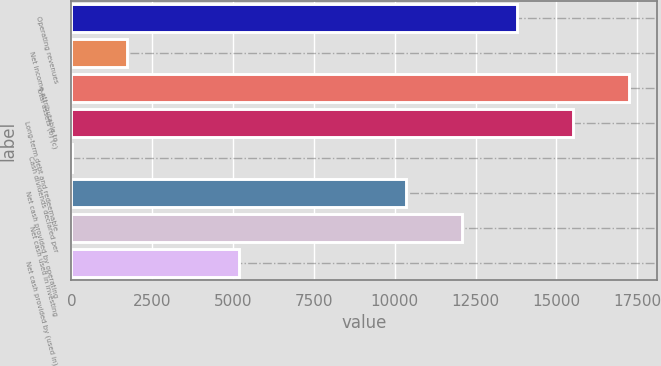Convert chart. <chart><loc_0><loc_0><loc_500><loc_500><bar_chart><fcel>Operating revenues<fcel>Net income attributable to<fcel>Total assets (b) (c)<fcel>Long-term debt and redeemable<fcel>Cash dividends declared per<fcel>Net cash provided by operating<fcel>Net cash used in investing<fcel>Net cash provided by (used in)<nl><fcel>13793<fcel>1725.32<fcel>17241<fcel>15517<fcel>1.36<fcel>10345.1<fcel>12069.1<fcel>5173.24<nl></chart> 